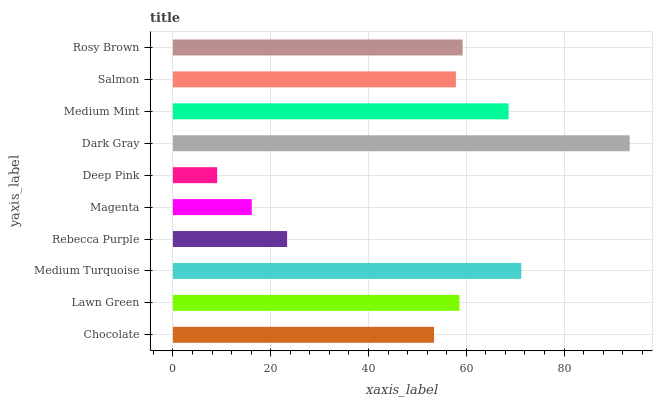Is Deep Pink the minimum?
Answer yes or no. Yes. Is Dark Gray the maximum?
Answer yes or no. Yes. Is Lawn Green the minimum?
Answer yes or no. No. Is Lawn Green the maximum?
Answer yes or no. No. Is Lawn Green greater than Chocolate?
Answer yes or no. Yes. Is Chocolate less than Lawn Green?
Answer yes or no. Yes. Is Chocolate greater than Lawn Green?
Answer yes or no. No. Is Lawn Green less than Chocolate?
Answer yes or no. No. Is Lawn Green the high median?
Answer yes or no. Yes. Is Salmon the low median?
Answer yes or no. Yes. Is Rosy Brown the high median?
Answer yes or no. No. Is Rosy Brown the low median?
Answer yes or no. No. 